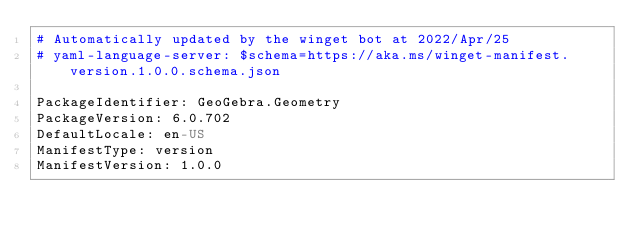Convert code to text. <code><loc_0><loc_0><loc_500><loc_500><_YAML_># Automatically updated by the winget bot at 2022/Apr/25
# yaml-language-server: $schema=https://aka.ms/winget-manifest.version.1.0.0.schema.json

PackageIdentifier: GeoGebra.Geometry
PackageVersion: 6.0.702
DefaultLocale: en-US
ManifestType: version
ManifestVersion: 1.0.0
</code> 